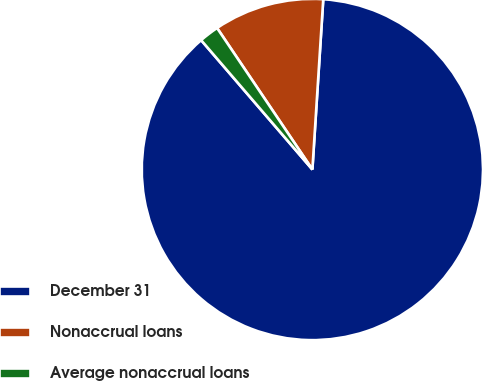Convert chart to OTSL. <chart><loc_0><loc_0><loc_500><loc_500><pie_chart><fcel>December 31<fcel>Nonaccrual loans<fcel>Average nonaccrual loans<nl><fcel>87.67%<fcel>10.45%<fcel>1.87%<nl></chart> 